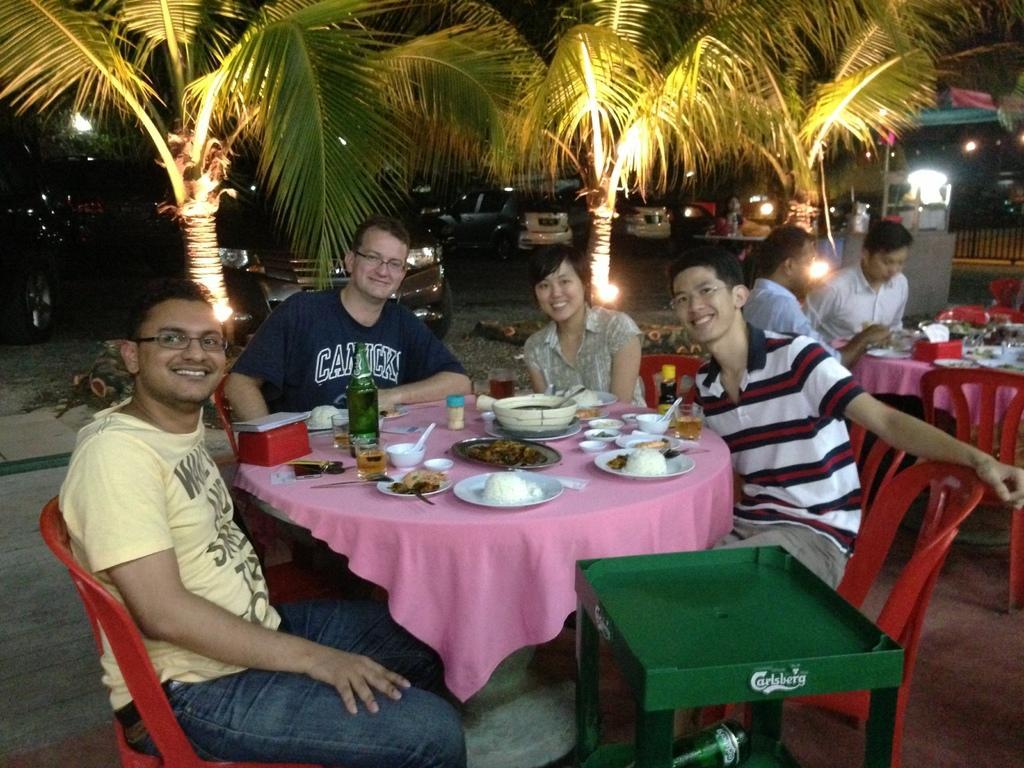In one or two sentences, can you explain what this image depicts? These persons are sitting on a chair. In-front of these persons there is a table, on a table there are plates, bowl, bottle, cup and spoon. Far there are vehicles. These are trees with lights. This is a cart, under this chart there is a bottle. 